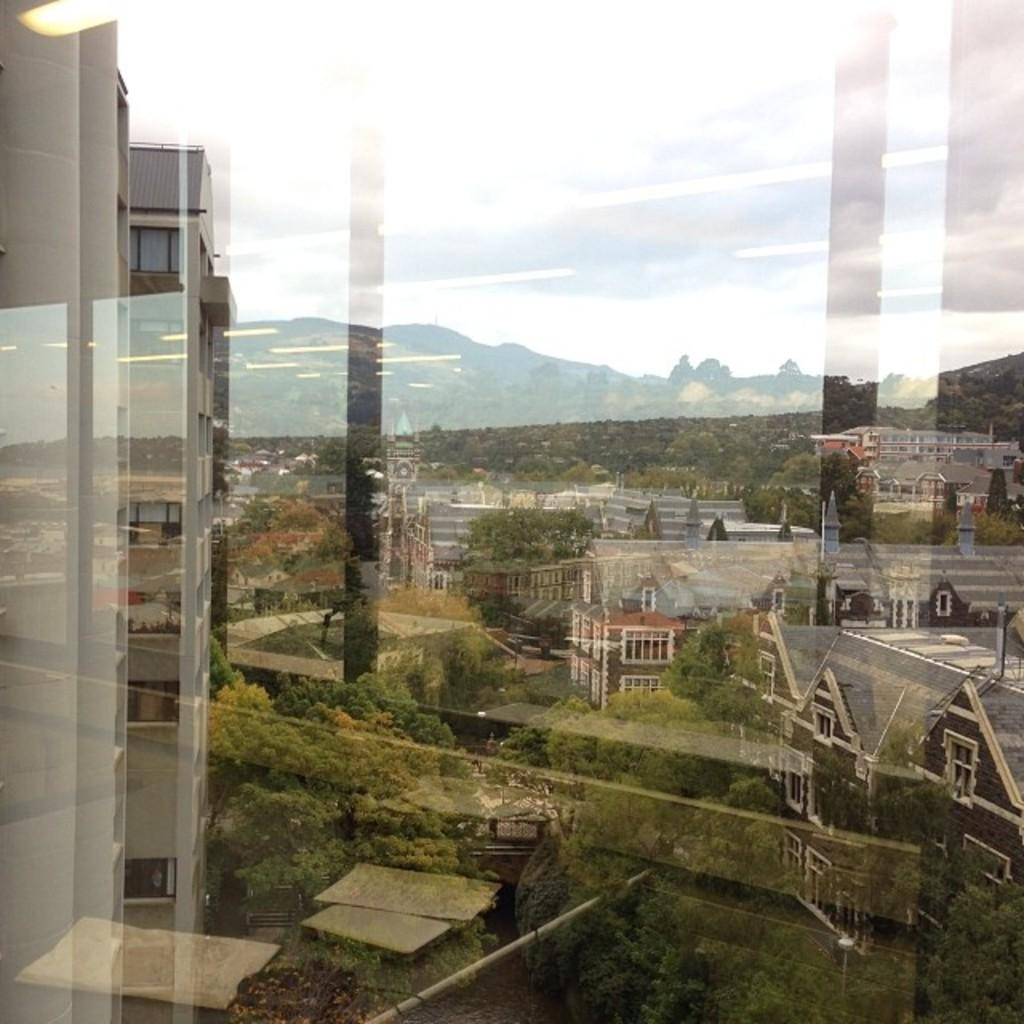What is the main object in the image? There is a glass in the image. What type of structures can be seen in the image? There are buildings in the image. What type of natural elements are present in the image? There are trees and mountains in the image. What else can be seen in the image besides the glass, buildings, trees, and mountains? There are objects in the image. What is visible in the background of the image? The sky is visible in the background of the image. How does the island look like in the image? There is no island present in the image. What type of part can be seen in the image? There is no specific part mentioned or visible in the image. 